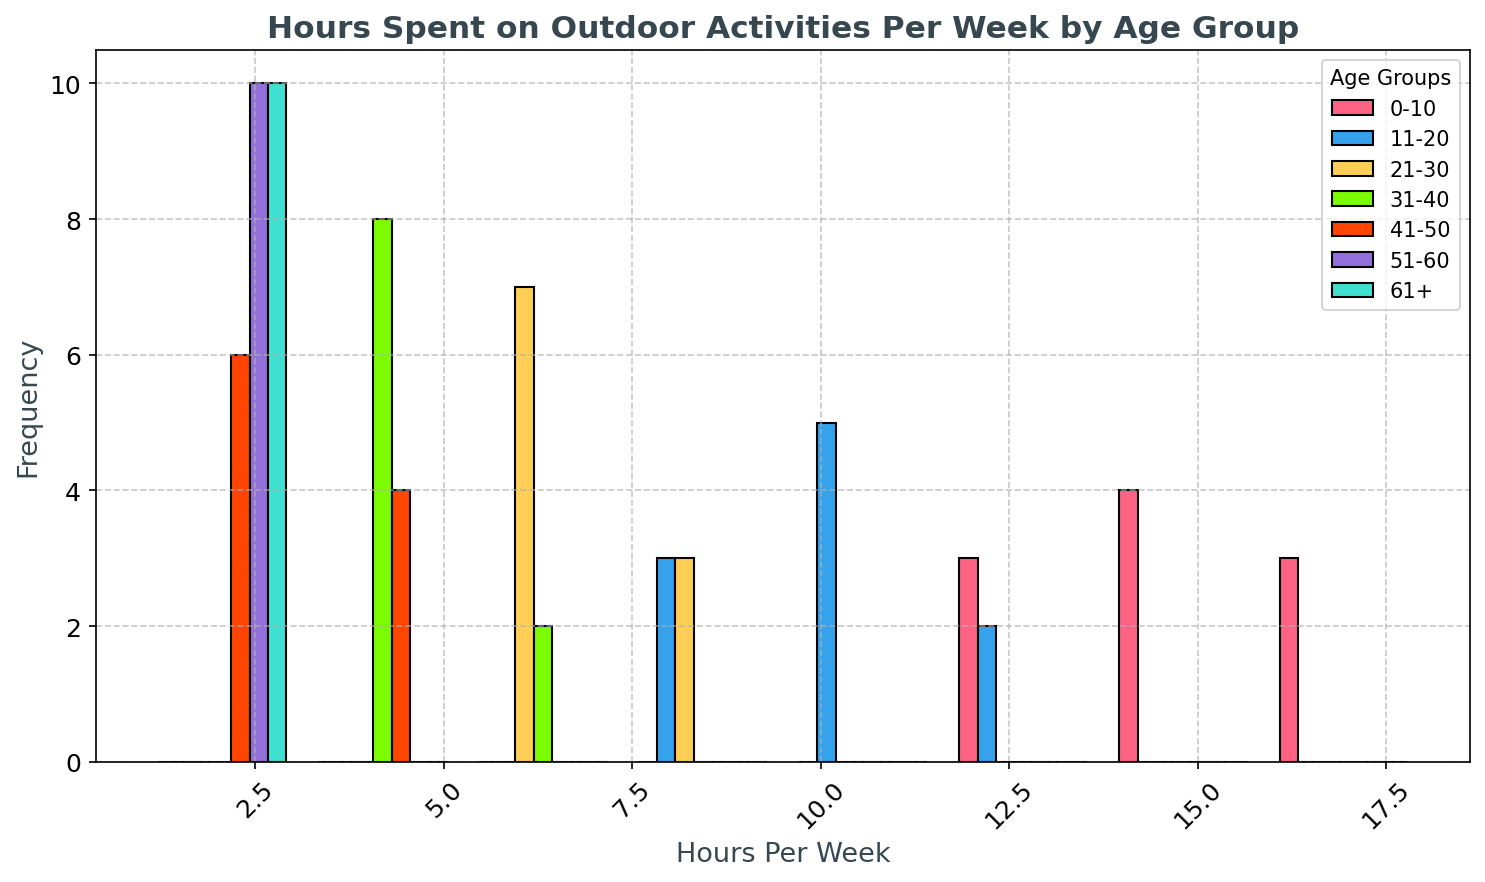How does the average number of hours spent on outdoor activities for the 0-10 age group compare to the 21-30 age group? First, calculate the average number of hours spent by the 0-10 age group: (14+12+16+15+14+13+17+18+12+15)/10 = 14.6. Then for the 21-30 age group: (7+6+8+7+6+9+7+8+6+7)/10 = 7.1. Comparing 14.6 and 7.1, we find the 0-10 age group spends more hours on outdoor activities.
Answer: The 0-10 age group spends more hours on outdoor activities Which age group has the highest frequency of individuals spending 2 hours per week on outdoor activities? By looking at the histogram, the frequencies for 2 hours per week are highest in the 51-60 and 61+ groups. Counting bars in the 51-60 group, it appears the frequency is higher than in the 61+ group.
Answer: 51-60 age group What is the range of hours spent on outdoor activities for the 11-20 age group? Look at the histogram range for the 11-20 age group. The minimum value appears to start at around 8, and the maximum ends at 13. Hence, the range is 13 - 8.
Answer: 5 hours Which age group has the widest distribution of hours spent on outdoor activities? By examining the spread of the histograms, the 0-10 age group spans from about 12-18, suggesting a distribution width of about 6 hours, which is the widest among the groups.
Answer: 0-10 age group How do the peak frequencies in the 31-40 and 41-50 age groups compare? The peak frequency in the 31-40 age group occurs at around 5 hours per week, while the peak for 41-50 happens around 3-4 hours per week. Comparing the heights visually, they appear to be approximately similar.
Answer: Similar frequencies How does the frequency of individuals spending between 1-2 hours differ between the 51-60 age group and the 61+ age group? For the 51-60 group, the histogram shows more individuals at 1-2 hours compared to the 61+ group. Specifically, count the heights of the bars at 1 and 2 hours, confirming a higher frequency for the 51-60 group.
Answer: More frequent in the 51-60 age group Which color in the histogram represents the highest frequency for spending 15 hours on outdoor activities? Cross-referencing the colors with the data labels for age groups, the color representing 0-10 years is noted for the 15-hour bar.
Answer: The color representing 0-10 age group In the 21-30 age group, how does the frequency of 9 hours compare to those spending 6 or 7 hours per week? Observing the histogram for the 21-30 group, the bar for 9 hours is lower compared to those for 6 or 7 hours.
Answer: Less frequent for 9 hours If you combine the frequencies of people spending exactly 12 hours in the 0-10 and 11-20 age groups, how many total individuals is that? Counting the number of bars at 12 hours in the 0-10 group (2) and the 11-20 group (1), we get a total of 2 + 1 = 3.
Answer: 3 individuals 